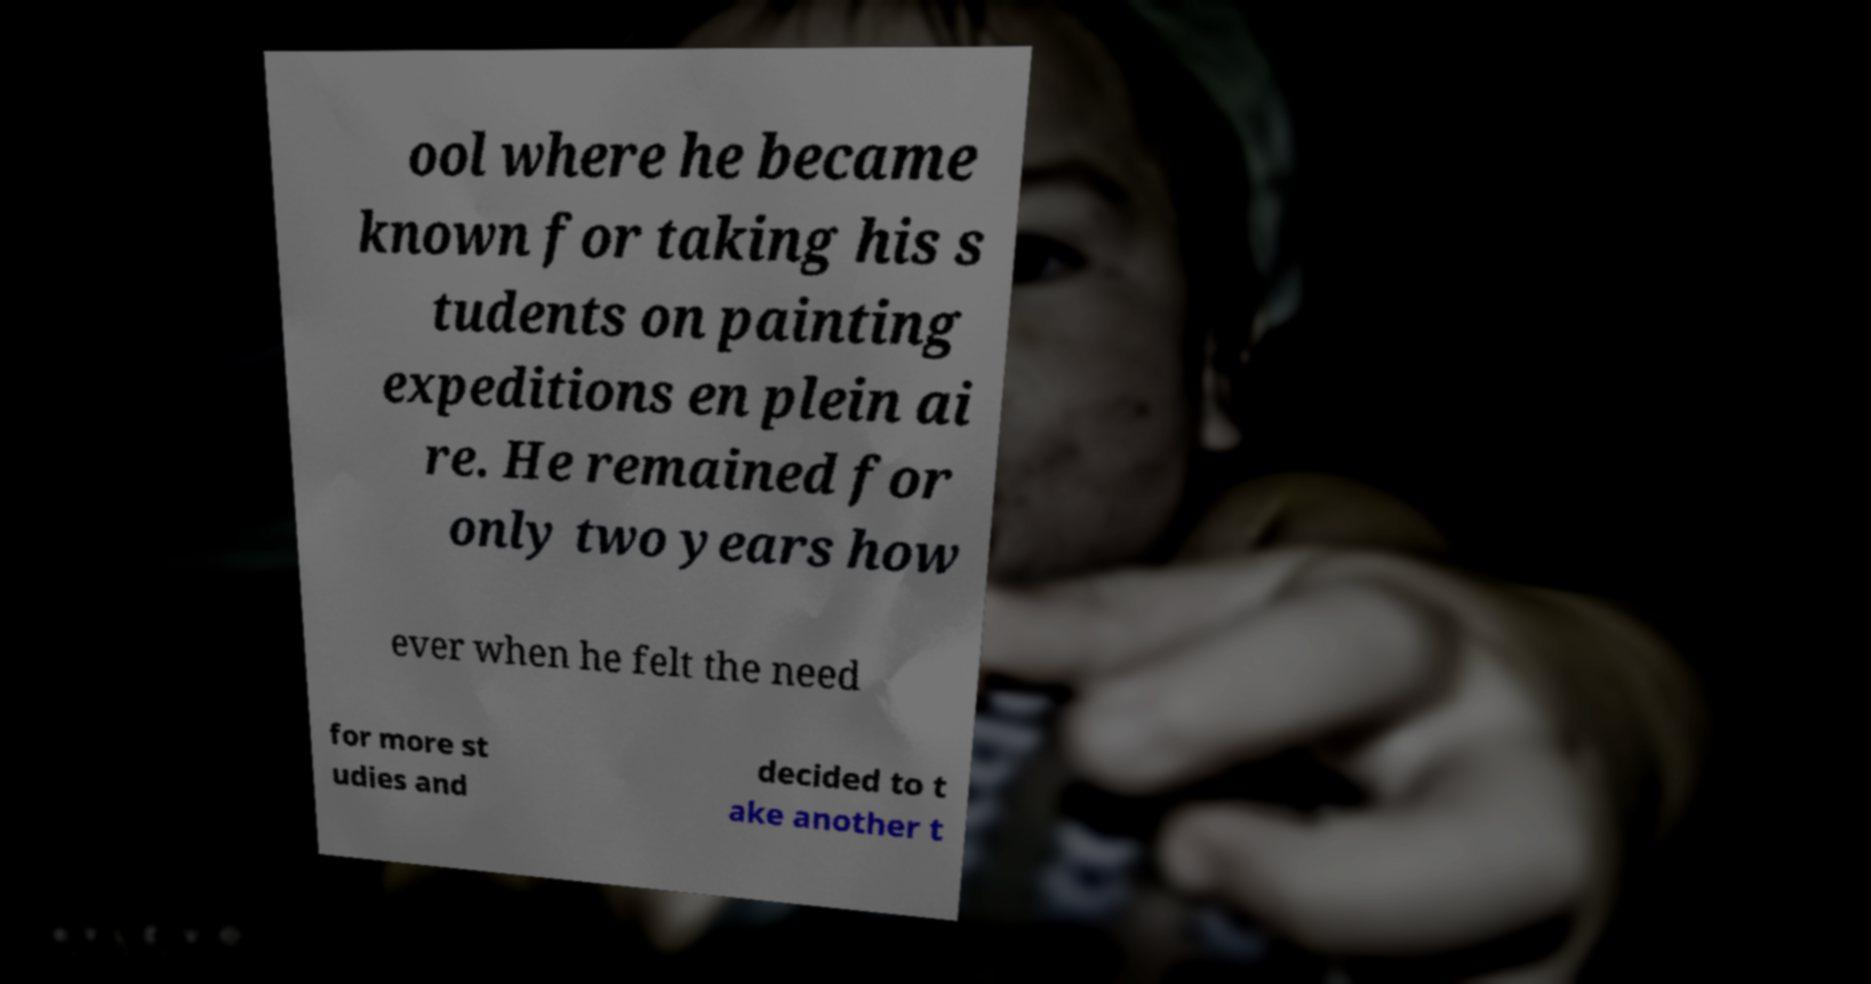There's text embedded in this image that I need extracted. Can you transcribe it verbatim? ool where he became known for taking his s tudents on painting expeditions en plein ai re. He remained for only two years how ever when he felt the need for more st udies and decided to t ake another t 